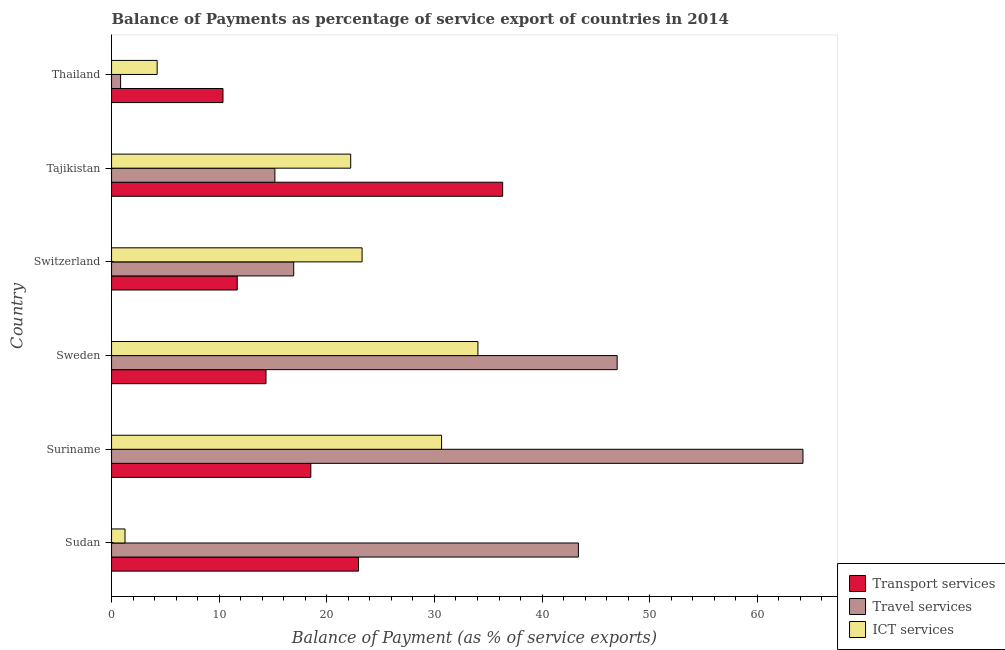Are the number of bars on each tick of the Y-axis equal?
Make the answer very short. Yes. How many bars are there on the 6th tick from the top?
Provide a short and direct response. 3. What is the label of the 2nd group of bars from the top?
Make the answer very short. Tajikistan. What is the balance of payment of transport services in Suriname?
Your response must be concise. 18.51. Across all countries, what is the maximum balance of payment of transport services?
Keep it short and to the point. 36.34. Across all countries, what is the minimum balance of payment of transport services?
Provide a succinct answer. 10.35. In which country was the balance of payment of transport services maximum?
Keep it short and to the point. Tajikistan. In which country was the balance of payment of transport services minimum?
Your response must be concise. Thailand. What is the total balance of payment of travel services in the graph?
Provide a succinct answer. 187.53. What is the difference between the balance of payment of travel services in Sudan and that in Suriname?
Make the answer very short. -20.87. What is the difference between the balance of payment of travel services in Suriname and the balance of payment of ict services in Sweden?
Provide a short and direct response. 30.2. What is the average balance of payment of transport services per country?
Give a very brief answer. 19.03. What is the difference between the balance of payment of transport services and balance of payment of travel services in Suriname?
Provide a succinct answer. -45.73. What is the ratio of the balance of payment of travel services in Switzerland to that in Thailand?
Ensure brevity in your answer.  20.12. Is the balance of payment of transport services in Sudan less than that in Switzerland?
Keep it short and to the point. No. What is the difference between the highest and the second highest balance of payment of ict services?
Give a very brief answer. 3.38. What is the difference between the highest and the lowest balance of payment of travel services?
Offer a very short reply. 63.4. What does the 3rd bar from the top in Tajikistan represents?
Keep it short and to the point. Transport services. What does the 3rd bar from the bottom in Tajikistan represents?
Make the answer very short. ICT services. What is the difference between two consecutive major ticks on the X-axis?
Make the answer very short. 10. Does the graph contain any zero values?
Offer a very short reply. No. Does the graph contain grids?
Your answer should be very brief. No. How many legend labels are there?
Make the answer very short. 3. What is the title of the graph?
Offer a very short reply. Balance of Payments as percentage of service export of countries in 2014. What is the label or title of the X-axis?
Give a very brief answer. Balance of Payment (as % of service exports). What is the label or title of the Y-axis?
Your answer should be compact. Country. What is the Balance of Payment (as % of service exports) in Transport services in Sudan?
Give a very brief answer. 22.95. What is the Balance of Payment (as % of service exports) of Travel services in Sudan?
Your answer should be very brief. 43.37. What is the Balance of Payment (as % of service exports) in ICT services in Sudan?
Offer a terse response. 1.25. What is the Balance of Payment (as % of service exports) in Transport services in Suriname?
Give a very brief answer. 18.51. What is the Balance of Payment (as % of service exports) in Travel services in Suriname?
Keep it short and to the point. 64.24. What is the Balance of Payment (as % of service exports) in ICT services in Suriname?
Offer a very short reply. 30.66. What is the Balance of Payment (as % of service exports) of Transport services in Sweden?
Ensure brevity in your answer.  14.35. What is the Balance of Payment (as % of service exports) of Travel services in Sweden?
Your response must be concise. 46.98. What is the Balance of Payment (as % of service exports) of ICT services in Sweden?
Provide a short and direct response. 34.04. What is the Balance of Payment (as % of service exports) in Transport services in Switzerland?
Offer a terse response. 11.68. What is the Balance of Payment (as % of service exports) in Travel services in Switzerland?
Your answer should be compact. 16.92. What is the Balance of Payment (as % of service exports) in ICT services in Switzerland?
Your answer should be compact. 23.28. What is the Balance of Payment (as % of service exports) in Transport services in Tajikistan?
Offer a terse response. 36.34. What is the Balance of Payment (as % of service exports) in Travel services in Tajikistan?
Ensure brevity in your answer.  15.18. What is the Balance of Payment (as % of service exports) of ICT services in Tajikistan?
Offer a very short reply. 22.22. What is the Balance of Payment (as % of service exports) of Transport services in Thailand?
Keep it short and to the point. 10.35. What is the Balance of Payment (as % of service exports) in Travel services in Thailand?
Make the answer very short. 0.84. What is the Balance of Payment (as % of service exports) of ICT services in Thailand?
Offer a very short reply. 4.24. Across all countries, what is the maximum Balance of Payment (as % of service exports) of Transport services?
Your answer should be very brief. 36.34. Across all countries, what is the maximum Balance of Payment (as % of service exports) of Travel services?
Offer a terse response. 64.24. Across all countries, what is the maximum Balance of Payment (as % of service exports) of ICT services?
Give a very brief answer. 34.04. Across all countries, what is the minimum Balance of Payment (as % of service exports) in Transport services?
Offer a terse response. 10.35. Across all countries, what is the minimum Balance of Payment (as % of service exports) of Travel services?
Ensure brevity in your answer.  0.84. Across all countries, what is the minimum Balance of Payment (as % of service exports) in ICT services?
Your response must be concise. 1.25. What is the total Balance of Payment (as % of service exports) in Transport services in the graph?
Your answer should be very brief. 114.18. What is the total Balance of Payment (as % of service exports) in Travel services in the graph?
Make the answer very short. 187.53. What is the total Balance of Payment (as % of service exports) of ICT services in the graph?
Give a very brief answer. 115.68. What is the difference between the Balance of Payment (as % of service exports) of Transport services in Sudan and that in Suriname?
Ensure brevity in your answer.  4.43. What is the difference between the Balance of Payment (as % of service exports) of Travel services in Sudan and that in Suriname?
Your answer should be compact. -20.87. What is the difference between the Balance of Payment (as % of service exports) of ICT services in Sudan and that in Suriname?
Provide a short and direct response. -29.41. What is the difference between the Balance of Payment (as % of service exports) in Transport services in Sudan and that in Sweden?
Your answer should be very brief. 8.59. What is the difference between the Balance of Payment (as % of service exports) in Travel services in Sudan and that in Sweden?
Your response must be concise. -3.6. What is the difference between the Balance of Payment (as % of service exports) in ICT services in Sudan and that in Sweden?
Make the answer very short. -32.79. What is the difference between the Balance of Payment (as % of service exports) in Transport services in Sudan and that in Switzerland?
Provide a short and direct response. 11.27. What is the difference between the Balance of Payment (as % of service exports) of Travel services in Sudan and that in Switzerland?
Your answer should be very brief. 26.45. What is the difference between the Balance of Payment (as % of service exports) in ICT services in Sudan and that in Switzerland?
Provide a short and direct response. -22.03. What is the difference between the Balance of Payment (as % of service exports) in Transport services in Sudan and that in Tajikistan?
Provide a succinct answer. -13.39. What is the difference between the Balance of Payment (as % of service exports) of Travel services in Sudan and that in Tajikistan?
Make the answer very short. 28.2. What is the difference between the Balance of Payment (as % of service exports) in ICT services in Sudan and that in Tajikistan?
Provide a short and direct response. -20.97. What is the difference between the Balance of Payment (as % of service exports) of Transport services in Sudan and that in Thailand?
Your answer should be compact. 12.59. What is the difference between the Balance of Payment (as % of service exports) in Travel services in Sudan and that in Thailand?
Offer a terse response. 42.53. What is the difference between the Balance of Payment (as % of service exports) in ICT services in Sudan and that in Thailand?
Provide a short and direct response. -2.99. What is the difference between the Balance of Payment (as % of service exports) in Transport services in Suriname and that in Sweden?
Provide a short and direct response. 4.16. What is the difference between the Balance of Payment (as % of service exports) of Travel services in Suriname and that in Sweden?
Provide a short and direct response. 17.26. What is the difference between the Balance of Payment (as % of service exports) of ICT services in Suriname and that in Sweden?
Offer a terse response. -3.38. What is the difference between the Balance of Payment (as % of service exports) in Transport services in Suriname and that in Switzerland?
Your response must be concise. 6.84. What is the difference between the Balance of Payment (as % of service exports) in Travel services in Suriname and that in Switzerland?
Your response must be concise. 47.32. What is the difference between the Balance of Payment (as % of service exports) in ICT services in Suriname and that in Switzerland?
Give a very brief answer. 7.39. What is the difference between the Balance of Payment (as % of service exports) in Transport services in Suriname and that in Tajikistan?
Offer a terse response. -17.82. What is the difference between the Balance of Payment (as % of service exports) of Travel services in Suriname and that in Tajikistan?
Provide a short and direct response. 49.07. What is the difference between the Balance of Payment (as % of service exports) of ICT services in Suriname and that in Tajikistan?
Your response must be concise. 8.44. What is the difference between the Balance of Payment (as % of service exports) of Transport services in Suriname and that in Thailand?
Offer a terse response. 8.16. What is the difference between the Balance of Payment (as % of service exports) of Travel services in Suriname and that in Thailand?
Ensure brevity in your answer.  63.4. What is the difference between the Balance of Payment (as % of service exports) of ICT services in Suriname and that in Thailand?
Offer a very short reply. 26.43. What is the difference between the Balance of Payment (as % of service exports) in Transport services in Sweden and that in Switzerland?
Offer a very short reply. 2.67. What is the difference between the Balance of Payment (as % of service exports) in Travel services in Sweden and that in Switzerland?
Your response must be concise. 30.05. What is the difference between the Balance of Payment (as % of service exports) of ICT services in Sweden and that in Switzerland?
Your response must be concise. 10.76. What is the difference between the Balance of Payment (as % of service exports) of Transport services in Sweden and that in Tajikistan?
Ensure brevity in your answer.  -21.99. What is the difference between the Balance of Payment (as % of service exports) in Travel services in Sweden and that in Tajikistan?
Ensure brevity in your answer.  31.8. What is the difference between the Balance of Payment (as % of service exports) in ICT services in Sweden and that in Tajikistan?
Provide a short and direct response. 11.82. What is the difference between the Balance of Payment (as % of service exports) of Transport services in Sweden and that in Thailand?
Offer a terse response. 4. What is the difference between the Balance of Payment (as % of service exports) in Travel services in Sweden and that in Thailand?
Give a very brief answer. 46.14. What is the difference between the Balance of Payment (as % of service exports) of ICT services in Sweden and that in Thailand?
Make the answer very short. 29.8. What is the difference between the Balance of Payment (as % of service exports) in Transport services in Switzerland and that in Tajikistan?
Offer a very short reply. -24.66. What is the difference between the Balance of Payment (as % of service exports) in Travel services in Switzerland and that in Tajikistan?
Your answer should be compact. 1.75. What is the difference between the Balance of Payment (as % of service exports) of ICT services in Switzerland and that in Tajikistan?
Provide a short and direct response. 1.06. What is the difference between the Balance of Payment (as % of service exports) in Transport services in Switzerland and that in Thailand?
Make the answer very short. 1.32. What is the difference between the Balance of Payment (as % of service exports) of Travel services in Switzerland and that in Thailand?
Provide a succinct answer. 16.08. What is the difference between the Balance of Payment (as % of service exports) in ICT services in Switzerland and that in Thailand?
Provide a short and direct response. 19.04. What is the difference between the Balance of Payment (as % of service exports) in Transport services in Tajikistan and that in Thailand?
Offer a very short reply. 25.98. What is the difference between the Balance of Payment (as % of service exports) in Travel services in Tajikistan and that in Thailand?
Offer a very short reply. 14.33. What is the difference between the Balance of Payment (as % of service exports) of ICT services in Tajikistan and that in Thailand?
Make the answer very short. 17.98. What is the difference between the Balance of Payment (as % of service exports) of Transport services in Sudan and the Balance of Payment (as % of service exports) of Travel services in Suriname?
Keep it short and to the point. -41.3. What is the difference between the Balance of Payment (as % of service exports) in Transport services in Sudan and the Balance of Payment (as % of service exports) in ICT services in Suriname?
Provide a short and direct response. -7.72. What is the difference between the Balance of Payment (as % of service exports) of Travel services in Sudan and the Balance of Payment (as % of service exports) of ICT services in Suriname?
Provide a short and direct response. 12.71. What is the difference between the Balance of Payment (as % of service exports) of Transport services in Sudan and the Balance of Payment (as % of service exports) of Travel services in Sweden?
Offer a terse response. -24.03. What is the difference between the Balance of Payment (as % of service exports) of Transport services in Sudan and the Balance of Payment (as % of service exports) of ICT services in Sweden?
Provide a short and direct response. -11.09. What is the difference between the Balance of Payment (as % of service exports) in Travel services in Sudan and the Balance of Payment (as % of service exports) in ICT services in Sweden?
Give a very brief answer. 9.34. What is the difference between the Balance of Payment (as % of service exports) in Transport services in Sudan and the Balance of Payment (as % of service exports) in Travel services in Switzerland?
Keep it short and to the point. 6.02. What is the difference between the Balance of Payment (as % of service exports) in Transport services in Sudan and the Balance of Payment (as % of service exports) in ICT services in Switzerland?
Make the answer very short. -0.33. What is the difference between the Balance of Payment (as % of service exports) in Travel services in Sudan and the Balance of Payment (as % of service exports) in ICT services in Switzerland?
Your answer should be very brief. 20.1. What is the difference between the Balance of Payment (as % of service exports) in Transport services in Sudan and the Balance of Payment (as % of service exports) in Travel services in Tajikistan?
Offer a very short reply. 7.77. What is the difference between the Balance of Payment (as % of service exports) of Transport services in Sudan and the Balance of Payment (as % of service exports) of ICT services in Tajikistan?
Keep it short and to the point. 0.73. What is the difference between the Balance of Payment (as % of service exports) in Travel services in Sudan and the Balance of Payment (as % of service exports) in ICT services in Tajikistan?
Offer a terse response. 21.16. What is the difference between the Balance of Payment (as % of service exports) in Transport services in Sudan and the Balance of Payment (as % of service exports) in Travel services in Thailand?
Give a very brief answer. 22.1. What is the difference between the Balance of Payment (as % of service exports) in Transport services in Sudan and the Balance of Payment (as % of service exports) in ICT services in Thailand?
Offer a very short reply. 18.71. What is the difference between the Balance of Payment (as % of service exports) in Travel services in Sudan and the Balance of Payment (as % of service exports) in ICT services in Thailand?
Offer a very short reply. 39.14. What is the difference between the Balance of Payment (as % of service exports) of Transport services in Suriname and the Balance of Payment (as % of service exports) of Travel services in Sweden?
Keep it short and to the point. -28.46. What is the difference between the Balance of Payment (as % of service exports) of Transport services in Suriname and the Balance of Payment (as % of service exports) of ICT services in Sweden?
Provide a succinct answer. -15.52. What is the difference between the Balance of Payment (as % of service exports) in Travel services in Suriname and the Balance of Payment (as % of service exports) in ICT services in Sweden?
Your response must be concise. 30.2. What is the difference between the Balance of Payment (as % of service exports) of Transport services in Suriname and the Balance of Payment (as % of service exports) of Travel services in Switzerland?
Keep it short and to the point. 1.59. What is the difference between the Balance of Payment (as % of service exports) in Transport services in Suriname and the Balance of Payment (as % of service exports) in ICT services in Switzerland?
Ensure brevity in your answer.  -4.76. What is the difference between the Balance of Payment (as % of service exports) in Travel services in Suriname and the Balance of Payment (as % of service exports) in ICT services in Switzerland?
Provide a short and direct response. 40.96. What is the difference between the Balance of Payment (as % of service exports) of Transport services in Suriname and the Balance of Payment (as % of service exports) of Travel services in Tajikistan?
Keep it short and to the point. 3.34. What is the difference between the Balance of Payment (as % of service exports) in Transport services in Suriname and the Balance of Payment (as % of service exports) in ICT services in Tajikistan?
Offer a very short reply. -3.7. What is the difference between the Balance of Payment (as % of service exports) of Travel services in Suriname and the Balance of Payment (as % of service exports) of ICT services in Tajikistan?
Your response must be concise. 42.02. What is the difference between the Balance of Payment (as % of service exports) of Transport services in Suriname and the Balance of Payment (as % of service exports) of Travel services in Thailand?
Give a very brief answer. 17.67. What is the difference between the Balance of Payment (as % of service exports) of Transport services in Suriname and the Balance of Payment (as % of service exports) of ICT services in Thailand?
Offer a terse response. 14.28. What is the difference between the Balance of Payment (as % of service exports) of Travel services in Suriname and the Balance of Payment (as % of service exports) of ICT services in Thailand?
Your response must be concise. 60. What is the difference between the Balance of Payment (as % of service exports) in Transport services in Sweden and the Balance of Payment (as % of service exports) in Travel services in Switzerland?
Offer a very short reply. -2.57. What is the difference between the Balance of Payment (as % of service exports) in Transport services in Sweden and the Balance of Payment (as % of service exports) in ICT services in Switzerland?
Keep it short and to the point. -8.93. What is the difference between the Balance of Payment (as % of service exports) in Travel services in Sweden and the Balance of Payment (as % of service exports) in ICT services in Switzerland?
Provide a short and direct response. 23.7. What is the difference between the Balance of Payment (as % of service exports) in Transport services in Sweden and the Balance of Payment (as % of service exports) in Travel services in Tajikistan?
Make the answer very short. -0.82. What is the difference between the Balance of Payment (as % of service exports) in Transport services in Sweden and the Balance of Payment (as % of service exports) in ICT services in Tajikistan?
Keep it short and to the point. -7.87. What is the difference between the Balance of Payment (as % of service exports) in Travel services in Sweden and the Balance of Payment (as % of service exports) in ICT services in Tajikistan?
Offer a terse response. 24.76. What is the difference between the Balance of Payment (as % of service exports) of Transport services in Sweden and the Balance of Payment (as % of service exports) of Travel services in Thailand?
Give a very brief answer. 13.51. What is the difference between the Balance of Payment (as % of service exports) in Transport services in Sweden and the Balance of Payment (as % of service exports) in ICT services in Thailand?
Provide a short and direct response. 10.12. What is the difference between the Balance of Payment (as % of service exports) in Travel services in Sweden and the Balance of Payment (as % of service exports) in ICT services in Thailand?
Offer a very short reply. 42.74. What is the difference between the Balance of Payment (as % of service exports) in Transport services in Switzerland and the Balance of Payment (as % of service exports) in Travel services in Tajikistan?
Make the answer very short. -3.5. What is the difference between the Balance of Payment (as % of service exports) of Transport services in Switzerland and the Balance of Payment (as % of service exports) of ICT services in Tajikistan?
Offer a very short reply. -10.54. What is the difference between the Balance of Payment (as % of service exports) in Travel services in Switzerland and the Balance of Payment (as % of service exports) in ICT services in Tajikistan?
Make the answer very short. -5.3. What is the difference between the Balance of Payment (as % of service exports) of Transport services in Switzerland and the Balance of Payment (as % of service exports) of Travel services in Thailand?
Make the answer very short. 10.84. What is the difference between the Balance of Payment (as % of service exports) of Transport services in Switzerland and the Balance of Payment (as % of service exports) of ICT services in Thailand?
Provide a short and direct response. 7.44. What is the difference between the Balance of Payment (as % of service exports) in Travel services in Switzerland and the Balance of Payment (as % of service exports) in ICT services in Thailand?
Make the answer very short. 12.69. What is the difference between the Balance of Payment (as % of service exports) in Transport services in Tajikistan and the Balance of Payment (as % of service exports) in Travel services in Thailand?
Offer a terse response. 35.5. What is the difference between the Balance of Payment (as % of service exports) of Transport services in Tajikistan and the Balance of Payment (as % of service exports) of ICT services in Thailand?
Your answer should be very brief. 32.1. What is the difference between the Balance of Payment (as % of service exports) of Travel services in Tajikistan and the Balance of Payment (as % of service exports) of ICT services in Thailand?
Provide a short and direct response. 10.94. What is the average Balance of Payment (as % of service exports) of Transport services per country?
Provide a short and direct response. 19.03. What is the average Balance of Payment (as % of service exports) of Travel services per country?
Give a very brief answer. 31.26. What is the average Balance of Payment (as % of service exports) of ICT services per country?
Ensure brevity in your answer.  19.28. What is the difference between the Balance of Payment (as % of service exports) of Transport services and Balance of Payment (as % of service exports) of Travel services in Sudan?
Your answer should be compact. -20.43. What is the difference between the Balance of Payment (as % of service exports) in Transport services and Balance of Payment (as % of service exports) in ICT services in Sudan?
Offer a very short reply. 21.7. What is the difference between the Balance of Payment (as % of service exports) in Travel services and Balance of Payment (as % of service exports) in ICT services in Sudan?
Your response must be concise. 42.12. What is the difference between the Balance of Payment (as % of service exports) of Transport services and Balance of Payment (as % of service exports) of Travel services in Suriname?
Your answer should be compact. -45.73. What is the difference between the Balance of Payment (as % of service exports) of Transport services and Balance of Payment (as % of service exports) of ICT services in Suriname?
Ensure brevity in your answer.  -12.15. What is the difference between the Balance of Payment (as % of service exports) of Travel services and Balance of Payment (as % of service exports) of ICT services in Suriname?
Make the answer very short. 33.58. What is the difference between the Balance of Payment (as % of service exports) of Transport services and Balance of Payment (as % of service exports) of Travel services in Sweden?
Make the answer very short. -32.62. What is the difference between the Balance of Payment (as % of service exports) of Transport services and Balance of Payment (as % of service exports) of ICT services in Sweden?
Your response must be concise. -19.69. What is the difference between the Balance of Payment (as % of service exports) of Travel services and Balance of Payment (as % of service exports) of ICT services in Sweden?
Provide a short and direct response. 12.94. What is the difference between the Balance of Payment (as % of service exports) in Transport services and Balance of Payment (as % of service exports) in Travel services in Switzerland?
Make the answer very short. -5.25. What is the difference between the Balance of Payment (as % of service exports) in Transport services and Balance of Payment (as % of service exports) in ICT services in Switzerland?
Make the answer very short. -11.6. What is the difference between the Balance of Payment (as % of service exports) in Travel services and Balance of Payment (as % of service exports) in ICT services in Switzerland?
Offer a terse response. -6.35. What is the difference between the Balance of Payment (as % of service exports) in Transport services and Balance of Payment (as % of service exports) in Travel services in Tajikistan?
Provide a short and direct response. 21.16. What is the difference between the Balance of Payment (as % of service exports) in Transport services and Balance of Payment (as % of service exports) in ICT services in Tajikistan?
Your response must be concise. 14.12. What is the difference between the Balance of Payment (as % of service exports) of Travel services and Balance of Payment (as % of service exports) of ICT services in Tajikistan?
Make the answer very short. -7.04. What is the difference between the Balance of Payment (as % of service exports) of Transport services and Balance of Payment (as % of service exports) of Travel services in Thailand?
Make the answer very short. 9.51. What is the difference between the Balance of Payment (as % of service exports) in Transport services and Balance of Payment (as % of service exports) in ICT services in Thailand?
Give a very brief answer. 6.12. What is the difference between the Balance of Payment (as % of service exports) in Travel services and Balance of Payment (as % of service exports) in ICT services in Thailand?
Give a very brief answer. -3.4. What is the ratio of the Balance of Payment (as % of service exports) in Transport services in Sudan to that in Suriname?
Provide a succinct answer. 1.24. What is the ratio of the Balance of Payment (as % of service exports) of Travel services in Sudan to that in Suriname?
Provide a short and direct response. 0.68. What is the ratio of the Balance of Payment (as % of service exports) of ICT services in Sudan to that in Suriname?
Offer a terse response. 0.04. What is the ratio of the Balance of Payment (as % of service exports) of Transport services in Sudan to that in Sweden?
Your response must be concise. 1.6. What is the ratio of the Balance of Payment (as % of service exports) in Travel services in Sudan to that in Sweden?
Provide a succinct answer. 0.92. What is the ratio of the Balance of Payment (as % of service exports) in ICT services in Sudan to that in Sweden?
Your answer should be very brief. 0.04. What is the ratio of the Balance of Payment (as % of service exports) of Transport services in Sudan to that in Switzerland?
Keep it short and to the point. 1.96. What is the ratio of the Balance of Payment (as % of service exports) of Travel services in Sudan to that in Switzerland?
Keep it short and to the point. 2.56. What is the ratio of the Balance of Payment (as % of service exports) of ICT services in Sudan to that in Switzerland?
Make the answer very short. 0.05. What is the ratio of the Balance of Payment (as % of service exports) in Transport services in Sudan to that in Tajikistan?
Your answer should be very brief. 0.63. What is the ratio of the Balance of Payment (as % of service exports) in Travel services in Sudan to that in Tajikistan?
Make the answer very short. 2.86. What is the ratio of the Balance of Payment (as % of service exports) in ICT services in Sudan to that in Tajikistan?
Offer a very short reply. 0.06. What is the ratio of the Balance of Payment (as % of service exports) in Transport services in Sudan to that in Thailand?
Keep it short and to the point. 2.22. What is the ratio of the Balance of Payment (as % of service exports) in Travel services in Sudan to that in Thailand?
Your answer should be compact. 51.57. What is the ratio of the Balance of Payment (as % of service exports) in ICT services in Sudan to that in Thailand?
Keep it short and to the point. 0.29. What is the ratio of the Balance of Payment (as % of service exports) of Transport services in Suriname to that in Sweden?
Your answer should be compact. 1.29. What is the ratio of the Balance of Payment (as % of service exports) in Travel services in Suriname to that in Sweden?
Make the answer very short. 1.37. What is the ratio of the Balance of Payment (as % of service exports) in ICT services in Suriname to that in Sweden?
Make the answer very short. 0.9. What is the ratio of the Balance of Payment (as % of service exports) in Transport services in Suriname to that in Switzerland?
Offer a very short reply. 1.59. What is the ratio of the Balance of Payment (as % of service exports) in Travel services in Suriname to that in Switzerland?
Make the answer very short. 3.8. What is the ratio of the Balance of Payment (as % of service exports) of ICT services in Suriname to that in Switzerland?
Your response must be concise. 1.32. What is the ratio of the Balance of Payment (as % of service exports) of Transport services in Suriname to that in Tajikistan?
Make the answer very short. 0.51. What is the ratio of the Balance of Payment (as % of service exports) in Travel services in Suriname to that in Tajikistan?
Offer a terse response. 4.23. What is the ratio of the Balance of Payment (as % of service exports) in ICT services in Suriname to that in Tajikistan?
Offer a very short reply. 1.38. What is the ratio of the Balance of Payment (as % of service exports) of Transport services in Suriname to that in Thailand?
Give a very brief answer. 1.79. What is the ratio of the Balance of Payment (as % of service exports) in Travel services in Suriname to that in Thailand?
Ensure brevity in your answer.  76.38. What is the ratio of the Balance of Payment (as % of service exports) in ICT services in Suriname to that in Thailand?
Provide a short and direct response. 7.24. What is the ratio of the Balance of Payment (as % of service exports) of Transport services in Sweden to that in Switzerland?
Keep it short and to the point. 1.23. What is the ratio of the Balance of Payment (as % of service exports) in Travel services in Sweden to that in Switzerland?
Keep it short and to the point. 2.78. What is the ratio of the Balance of Payment (as % of service exports) of ICT services in Sweden to that in Switzerland?
Offer a very short reply. 1.46. What is the ratio of the Balance of Payment (as % of service exports) of Transport services in Sweden to that in Tajikistan?
Give a very brief answer. 0.4. What is the ratio of the Balance of Payment (as % of service exports) in Travel services in Sweden to that in Tajikistan?
Your answer should be compact. 3.1. What is the ratio of the Balance of Payment (as % of service exports) in ICT services in Sweden to that in Tajikistan?
Provide a succinct answer. 1.53. What is the ratio of the Balance of Payment (as % of service exports) of Transport services in Sweden to that in Thailand?
Your answer should be compact. 1.39. What is the ratio of the Balance of Payment (as % of service exports) of Travel services in Sweden to that in Thailand?
Make the answer very short. 55.85. What is the ratio of the Balance of Payment (as % of service exports) of ICT services in Sweden to that in Thailand?
Keep it short and to the point. 8.04. What is the ratio of the Balance of Payment (as % of service exports) of Transport services in Switzerland to that in Tajikistan?
Offer a terse response. 0.32. What is the ratio of the Balance of Payment (as % of service exports) of Travel services in Switzerland to that in Tajikistan?
Provide a short and direct response. 1.12. What is the ratio of the Balance of Payment (as % of service exports) in ICT services in Switzerland to that in Tajikistan?
Keep it short and to the point. 1.05. What is the ratio of the Balance of Payment (as % of service exports) in Transport services in Switzerland to that in Thailand?
Give a very brief answer. 1.13. What is the ratio of the Balance of Payment (as % of service exports) in Travel services in Switzerland to that in Thailand?
Your answer should be very brief. 20.12. What is the ratio of the Balance of Payment (as % of service exports) of ICT services in Switzerland to that in Thailand?
Your response must be concise. 5.49. What is the ratio of the Balance of Payment (as % of service exports) of Transport services in Tajikistan to that in Thailand?
Provide a succinct answer. 3.51. What is the ratio of the Balance of Payment (as % of service exports) of Travel services in Tajikistan to that in Thailand?
Make the answer very short. 18.04. What is the ratio of the Balance of Payment (as % of service exports) of ICT services in Tajikistan to that in Thailand?
Give a very brief answer. 5.24. What is the difference between the highest and the second highest Balance of Payment (as % of service exports) of Transport services?
Ensure brevity in your answer.  13.39. What is the difference between the highest and the second highest Balance of Payment (as % of service exports) in Travel services?
Your answer should be compact. 17.26. What is the difference between the highest and the second highest Balance of Payment (as % of service exports) of ICT services?
Offer a very short reply. 3.38. What is the difference between the highest and the lowest Balance of Payment (as % of service exports) of Transport services?
Ensure brevity in your answer.  25.98. What is the difference between the highest and the lowest Balance of Payment (as % of service exports) of Travel services?
Keep it short and to the point. 63.4. What is the difference between the highest and the lowest Balance of Payment (as % of service exports) in ICT services?
Ensure brevity in your answer.  32.79. 